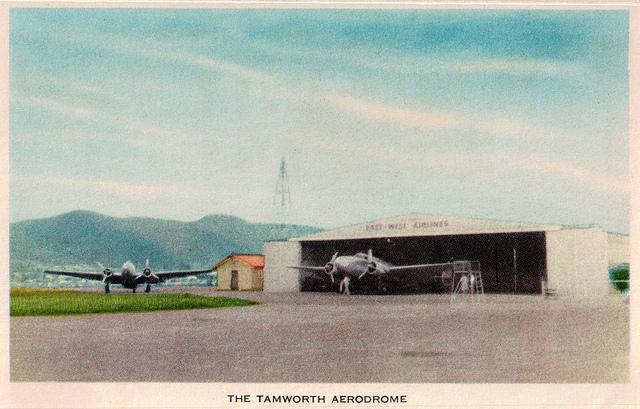Where is the silver plane on the right being stored?

Choices:
A) home
B) hotel
C) hanger
D) shed hanger 